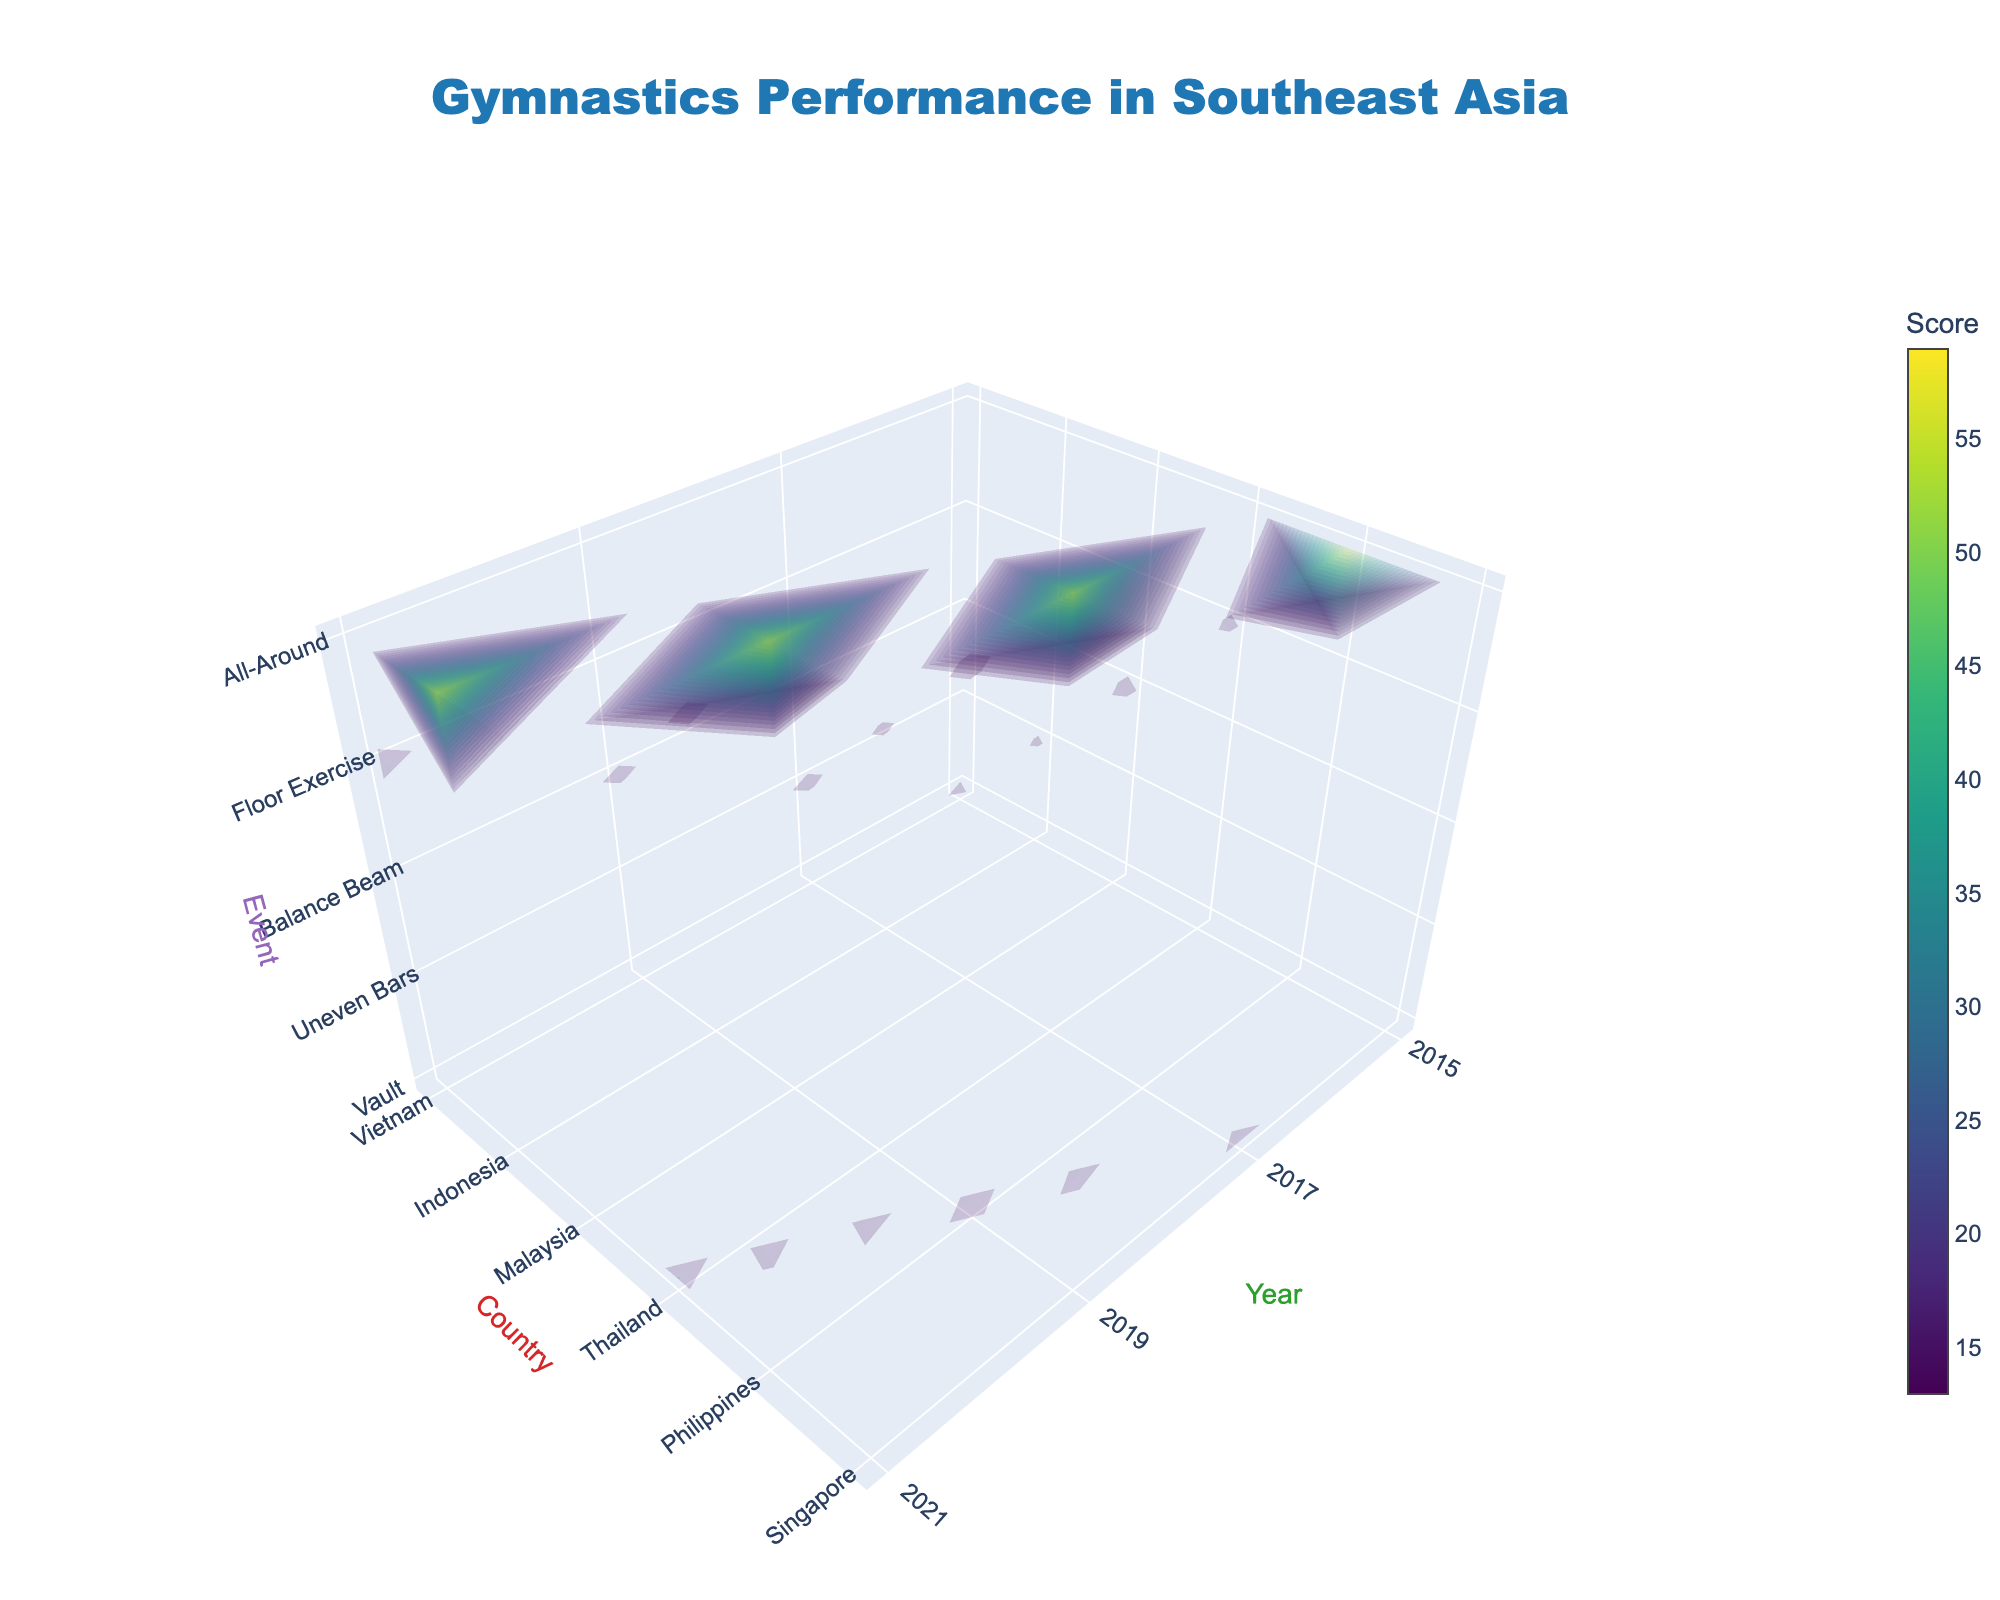What is the title of the 3D volume plot? The title is the text prominently displayed at the top of the visualization. The title provides an overview of the dataset or trend being visualized.
Answer: Gymnastics Performance in Southeast Asia What does the color scale represent in the plot? The color scale is labeled 'Score,' which indicates that it maps the gymnastic performance scores to different colors. The different shades help identify higher and lower scores.
Answer: Score Which country had the highest score in the Vault event in 2021? By locating 2021 on the Year axis, Thailand on the Country axis, and Vault on the Event axis, the highest score of 15.1 can be observed.
Answer: Thailand How many unique events are displayed in the plot? The axis labeled 'Event' has tick marks for each unique gymnastic event. Counting these tick marks reveals the number of events.
Answer: 5 What are the years displayed on the 'Year' axis? The tick marks on the 'Year' axis represent individual years. These years are taken from the dataset.
Answer: 2015, 2017, 2019, 2021 Which event had the highest score across all years and countries? By examining the peaks along the Event axis, the highest score across all events can be seen. The score of 58.5 in the All-Around event in 2021 stands out.
Answer: All-Around How does Vietnam's score in the Balance Beam event change from 2015 to 2021? By tracking Vietnam's Balance Beam scores from 2015 (14.2) to 2019 (14.2) and seeing no records for 2017 and 2021, it appears that scores for those years are missing or Vietnam didn't participate.
Answer: No Change Which country showed improvement in Uneven Bars from 2015 to 2021? Looking at the scores for Uneven Bars across different countries over the specified years, the Philippines shows improvement from 2015 (13.8) to 2021 (14.7).
Answer: Philippines Compare the overall performance in All-Around event between Malaysia and Indonesia. Using the All-Around scores, Malaysia's highest is 57.2 in 2019, and Indonesia's highest is 58.5 in 2021, indicating Indonesia performed better overall in the All-Around event.
Answer: Indonesia What is the maximum score observed in Floor Exercise, and which country achieved it? Looking along the Floor Exercise axis, Vietnam holds the maximum score of 14.9, achieved in 2021.
Answer: Vietnam 